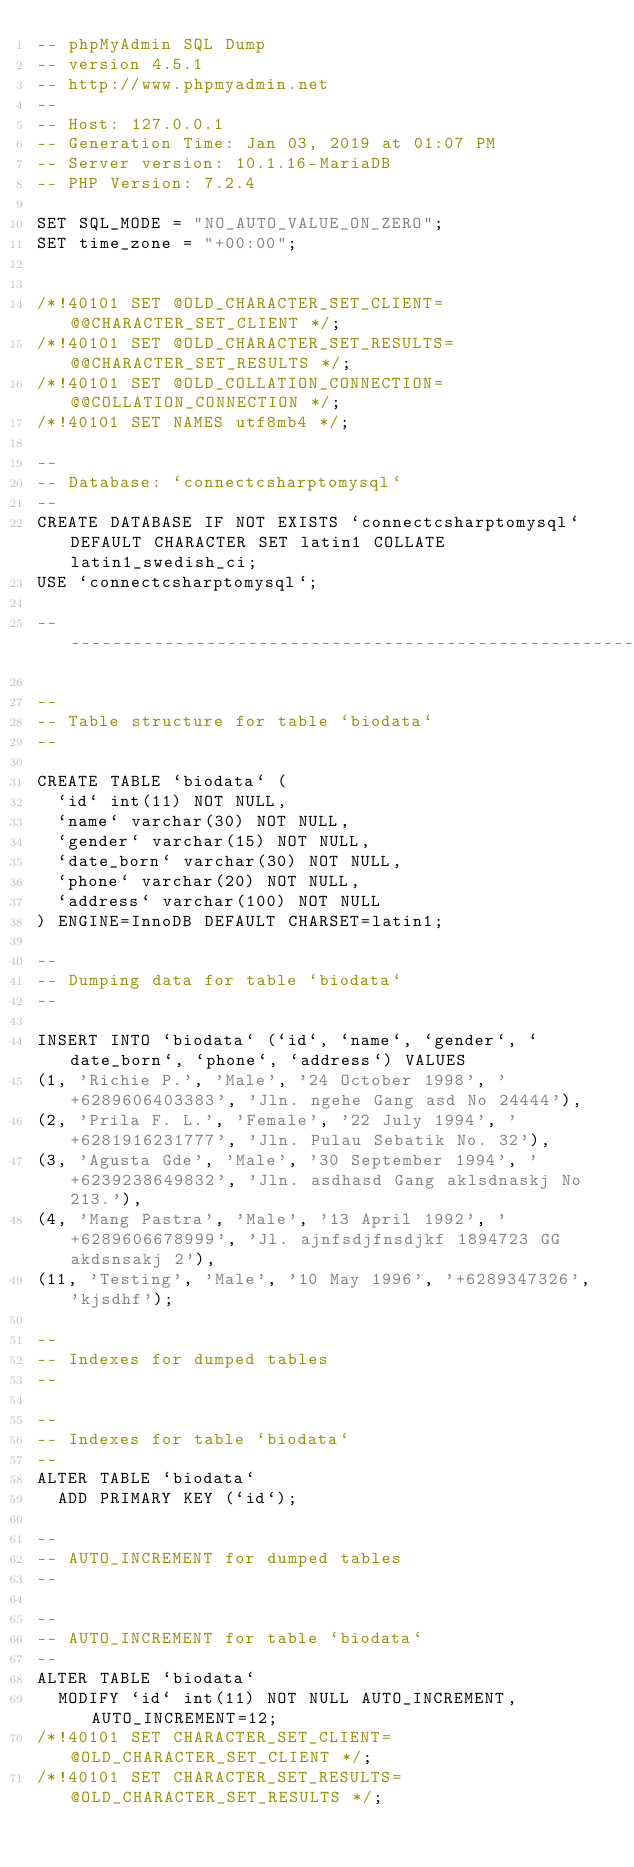Convert code to text. <code><loc_0><loc_0><loc_500><loc_500><_SQL_>-- phpMyAdmin SQL Dump
-- version 4.5.1
-- http://www.phpmyadmin.net
--
-- Host: 127.0.0.1
-- Generation Time: Jan 03, 2019 at 01:07 PM
-- Server version: 10.1.16-MariaDB
-- PHP Version: 7.2.4

SET SQL_MODE = "NO_AUTO_VALUE_ON_ZERO";
SET time_zone = "+00:00";


/*!40101 SET @OLD_CHARACTER_SET_CLIENT=@@CHARACTER_SET_CLIENT */;
/*!40101 SET @OLD_CHARACTER_SET_RESULTS=@@CHARACTER_SET_RESULTS */;
/*!40101 SET @OLD_COLLATION_CONNECTION=@@COLLATION_CONNECTION */;
/*!40101 SET NAMES utf8mb4 */;

--
-- Database: `connectcsharptomysql`
--
CREATE DATABASE IF NOT EXISTS `connectcsharptomysql` DEFAULT CHARACTER SET latin1 COLLATE latin1_swedish_ci;
USE `connectcsharptomysql`;

-- --------------------------------------------------------

--
-- Table structure for table `biodata`
--

CREATE TABLE `biodata` (
  `id` int(11) NOT NULL,
  `name` varchar(30) NOT NULL,
  `gender` varchar(15) NOT NULL,
  `date_born` varchar(30) NOT NULL,
  `phone` varchar(20) NOT NULL,
  `address` varchar(100) NOT NULL
) ENGINE=InnoDB DEFAULT CHARSET=latin1;

--
-- Dumping data for table `biodata`
--

INSERT INTO `biodata` (`id`, `name`, `gender`, `date_born`, `phone`, `address`) VALUES
(1, 'Richie P.', 'Male', '24 October 1998', '+6289606403383', 'Jln. ngehe Gang asd No 24444'),
(2, 'Prila F. L.', 'Female', '22 July 1994', '+6281916231777', 'Jln. Pulau Sebatik No. 32'),
(3, 'Agusta Gde', 'Male', '30 September 1994', '+6239238649832', 'Jln. asdhasd Gang aklsdnaskj No 213.'),
(4, 'Mang Pastra', 'Male', '13 April 1992', '+6289606678999', 'Jl. ajnfsdjfnsdjkf 1894723 GG akdsnsakj 2'),
(11, 'Testing', 'Male', '10 May 1996', '+6289347326', 'kjsdhf');

--
-- Indexes for dumped tables
--

--
-- Indexes for table `biodata`
--
ALTER TABLE `biodata`
  ADD PRIMARY KEY (`id`);

--
-- AUTO_INCREMENT for dumped tables
--

--
-- AUTO_INCREMENT for table `biodata`
--
ALTER TABLE `biodata`
  MODIFY `id` int(11) NOT NULL AUTO_INCREMENT, AUTO_INCREMENT=12;
/*!40101 SET CHARACTER_SET_CLIENT=@OLD_CHARACTER_SET_CLIENT */;
/*!40101 SET CHARACTER_SET_RESULTS=@OLD_CHARACTER_SET_RESULTS */;</code> 